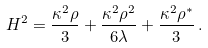<formula> <loc_0><loc_0><loc_500><loc_500>H ^ { 2 } = \frac { \kappa ^ { 2 } \rho } { 3 } + \frac { \kappa ^ { 2 } \rho ^ { 2 } } { 6 \lambda } + \frac { \kappa ^ { 2 } \rho ^ { * } } { 3 } \, .</formula> 